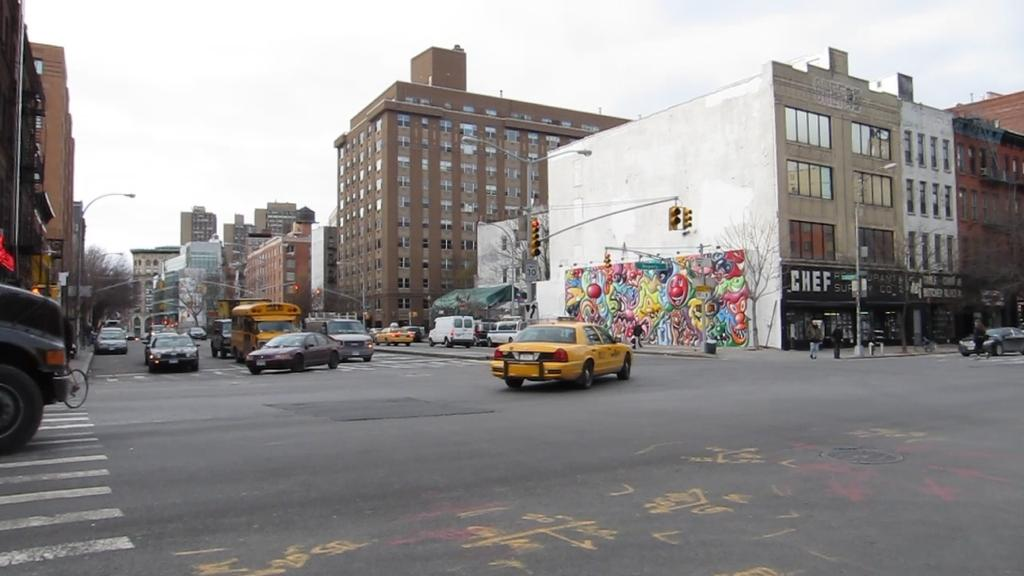<image>
Write a terse but informative summary of the picture. The building where Chef is located is on the corner of the street. 